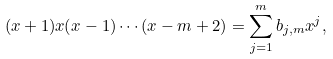<formula> <loc_0><loc_0><loc_500><loc_500>( x + 1 ) x ( x - 1 ) \cdots ( x - m + 2 ) = \sum _ { j = 1 } ^ { m } b _ { j , m } x ^ { j } ,</formula> 